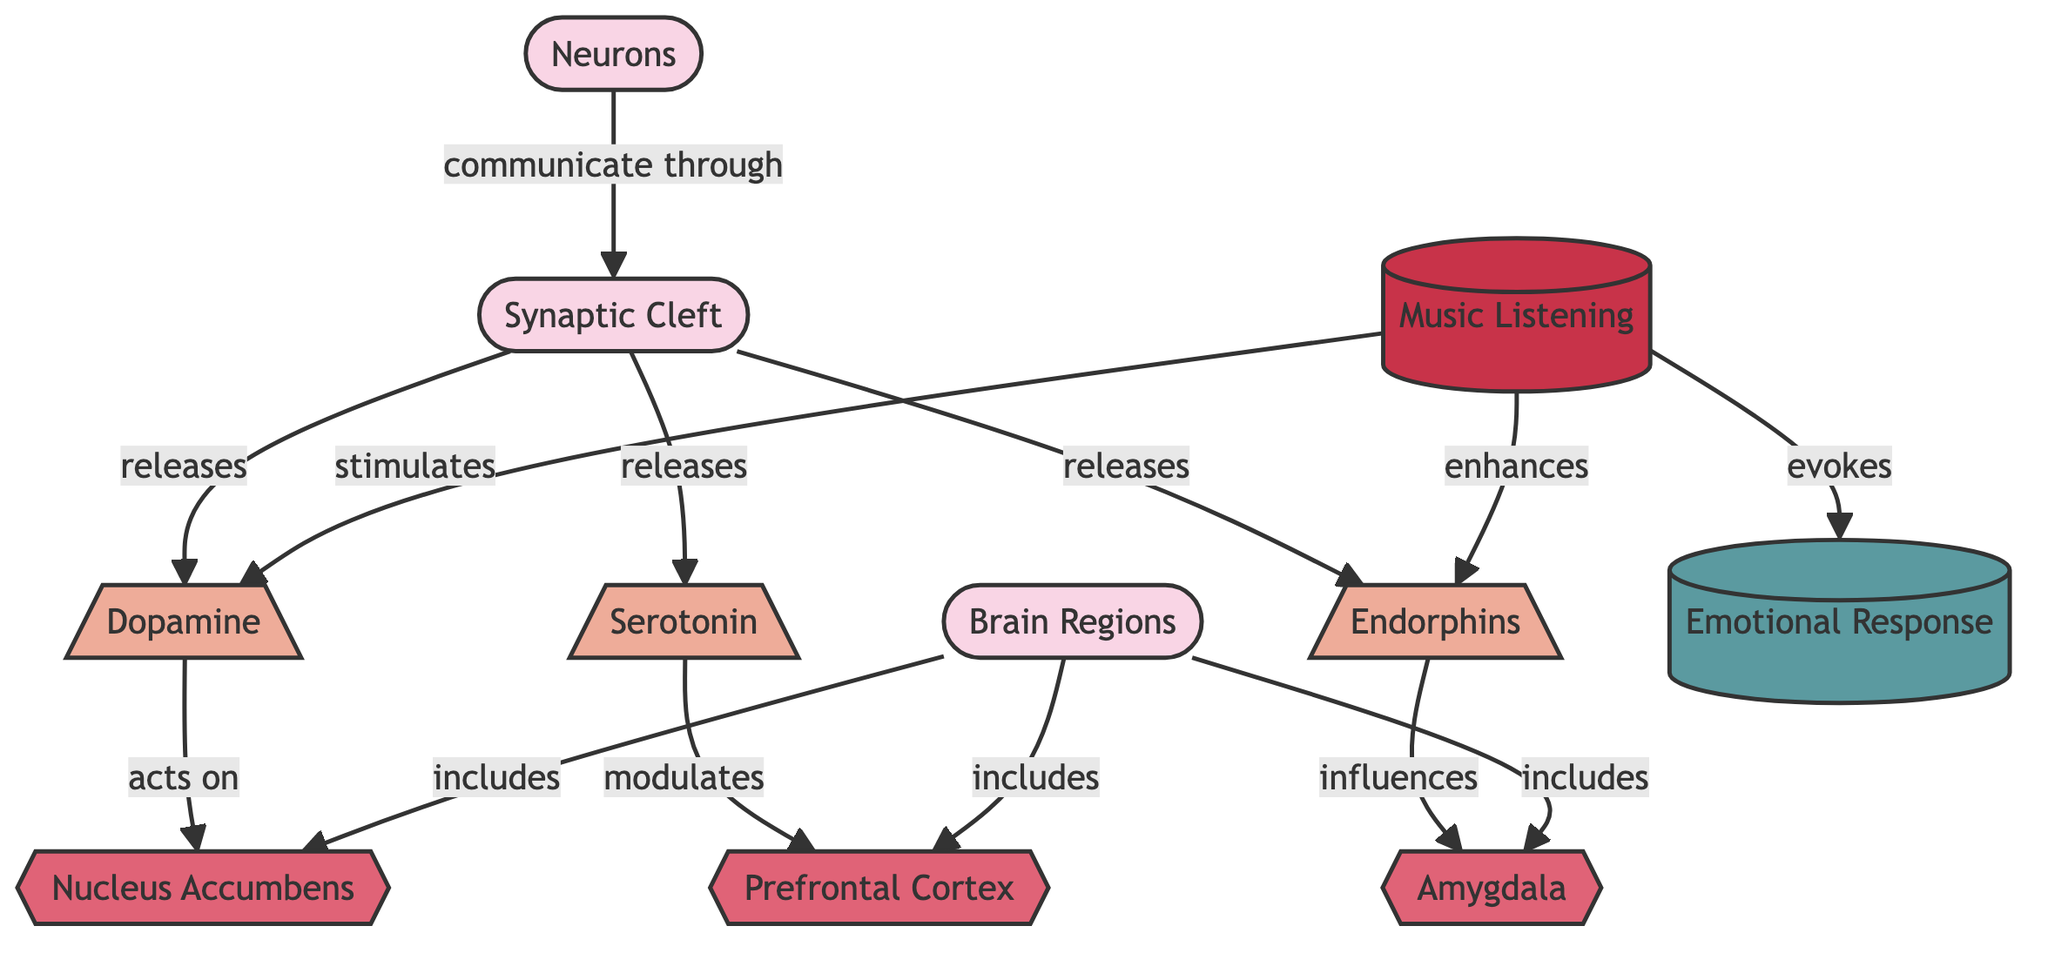What neurotransmitter is released from the synaptic cleft? The diagram indicates that dopamine, serotonin, and endorphins are released from the synaptic cleft when neurons communicate.
Answer: Dopamine, serotonin, endorphins How many brain regions are included in the diagram? The diagram lists three brain regions: the prefrontal cortex, nucleus accumbens, and amygdala. Thus, the total is three brain regions.
Answer: 3 Which brain region does dopamine act on? The diagram shows that dopamine acts on the nucleus accumbens. This is indicated by the direct connection from dopamine to the nucleus accumbens in the flowchart.
Answer: Nucleus Accumbens What effect does music listening have on endorphins? According to the flowchart, music listening enhances endorphins, implying that there is a stimulatory relationship between the two.
Answer: Enhances Which neurotransmitter modulates the prefrontal cortex? The diagram specifies that serotonin modulates the prefrontal cortex, indicating the directional flow from serotonin to this brain region.
Answer: Serotonin What phenomenon is evoked by music listening? The diagram depicts that music listening evokes an emotional response, showing the relationship between music listening and the resulting phenomenon.
Answer: Emotional Response How do endorphins influence emotion according to the diagram? The diagram specifies that endorphins influence the amygdala, which is involved in processing emotions, indicating that endorphins have an emotional impact through this brain region.
Answer: Influences What is the primary activity depicted in the diagram? The diagram highlights "music listening" as the main activity that initiates interactions between neurotransmitters and brain regions.
Answer: Music Listening How are neurons related to the synaptic cleft? The flowchart illustrates that neurons communicate through the synaptic cleft, indicating a directional relationship between the two components in the diagram.
Answer: Communicate through 